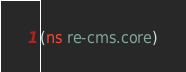<code> <loc_0><loc_0><loc_500><loc_500><_Clojure_>(ns re-cms.core)
</code> 